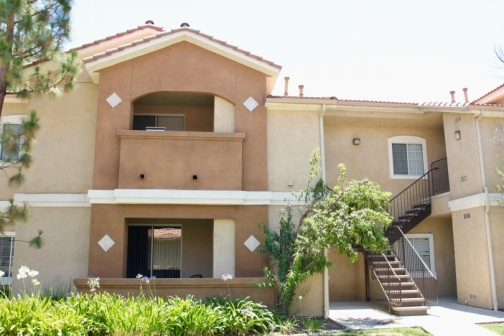Imagine a resident coming home. What would their experience be like? A resident coming home to this apartment complex would be greeted by a peaceful and welcoming atmosphere. Upon arriving, they would notice the well-kept lawn and the soothing colors of the building. As they walk up the stairs or through the patio, the quiet surrounding and lush greenery would provide a sense of calm and relaxation, a perfect detour from the bustling world outside. 